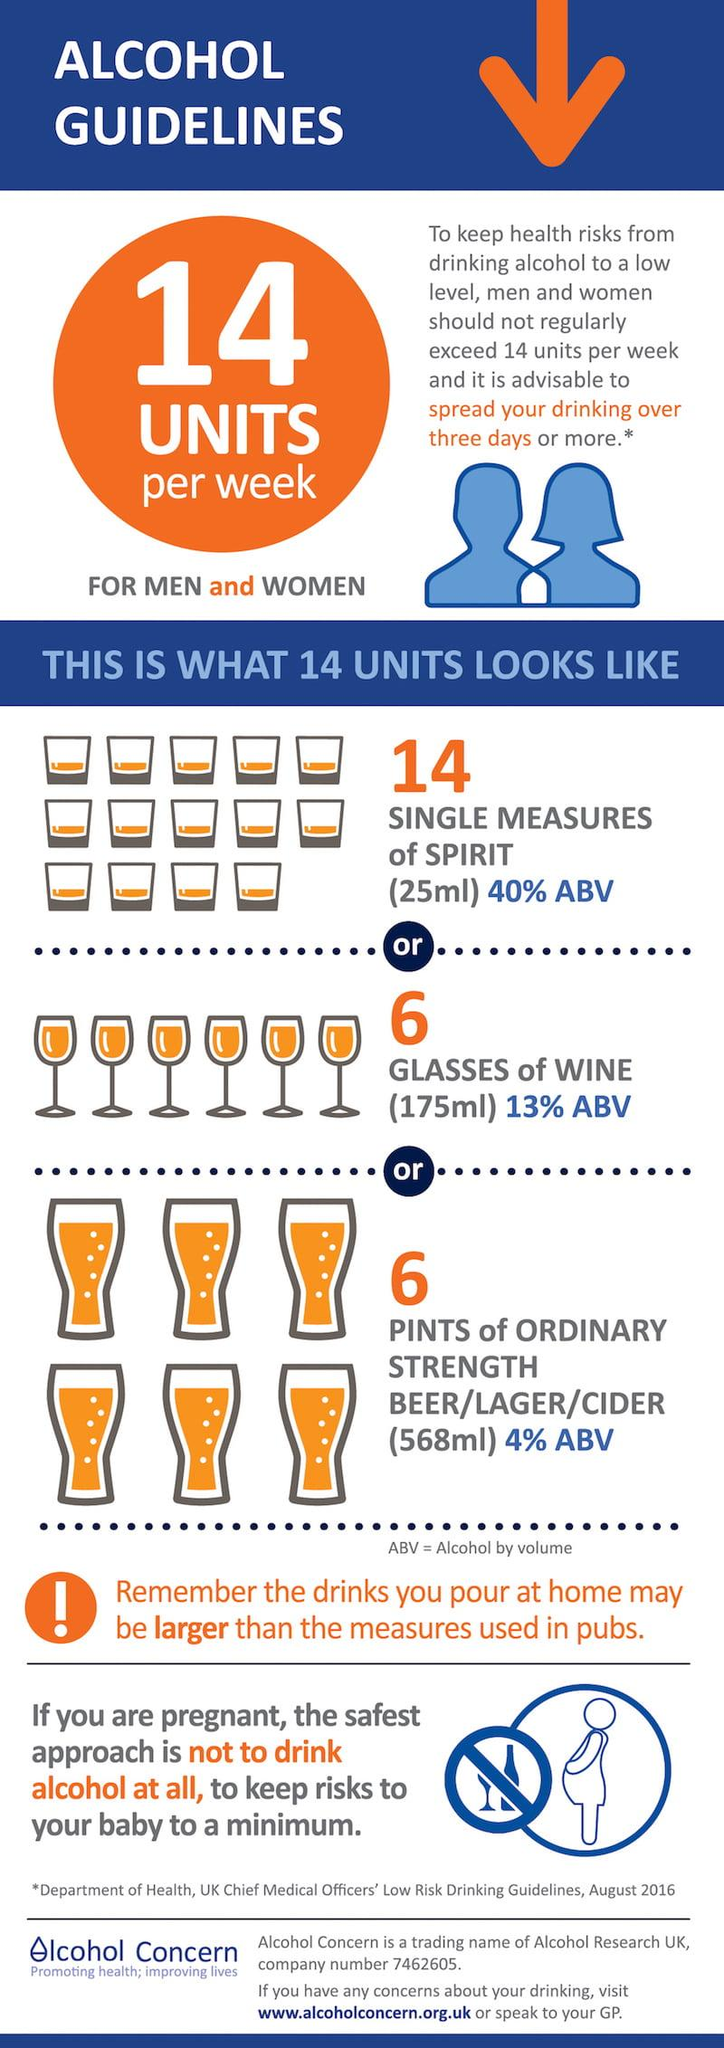Give some essential details in this illustration. The number of pregnant lady icons in this infographic is one. The color of number six is orange. There are three types of glasses depicted in this infographic. 